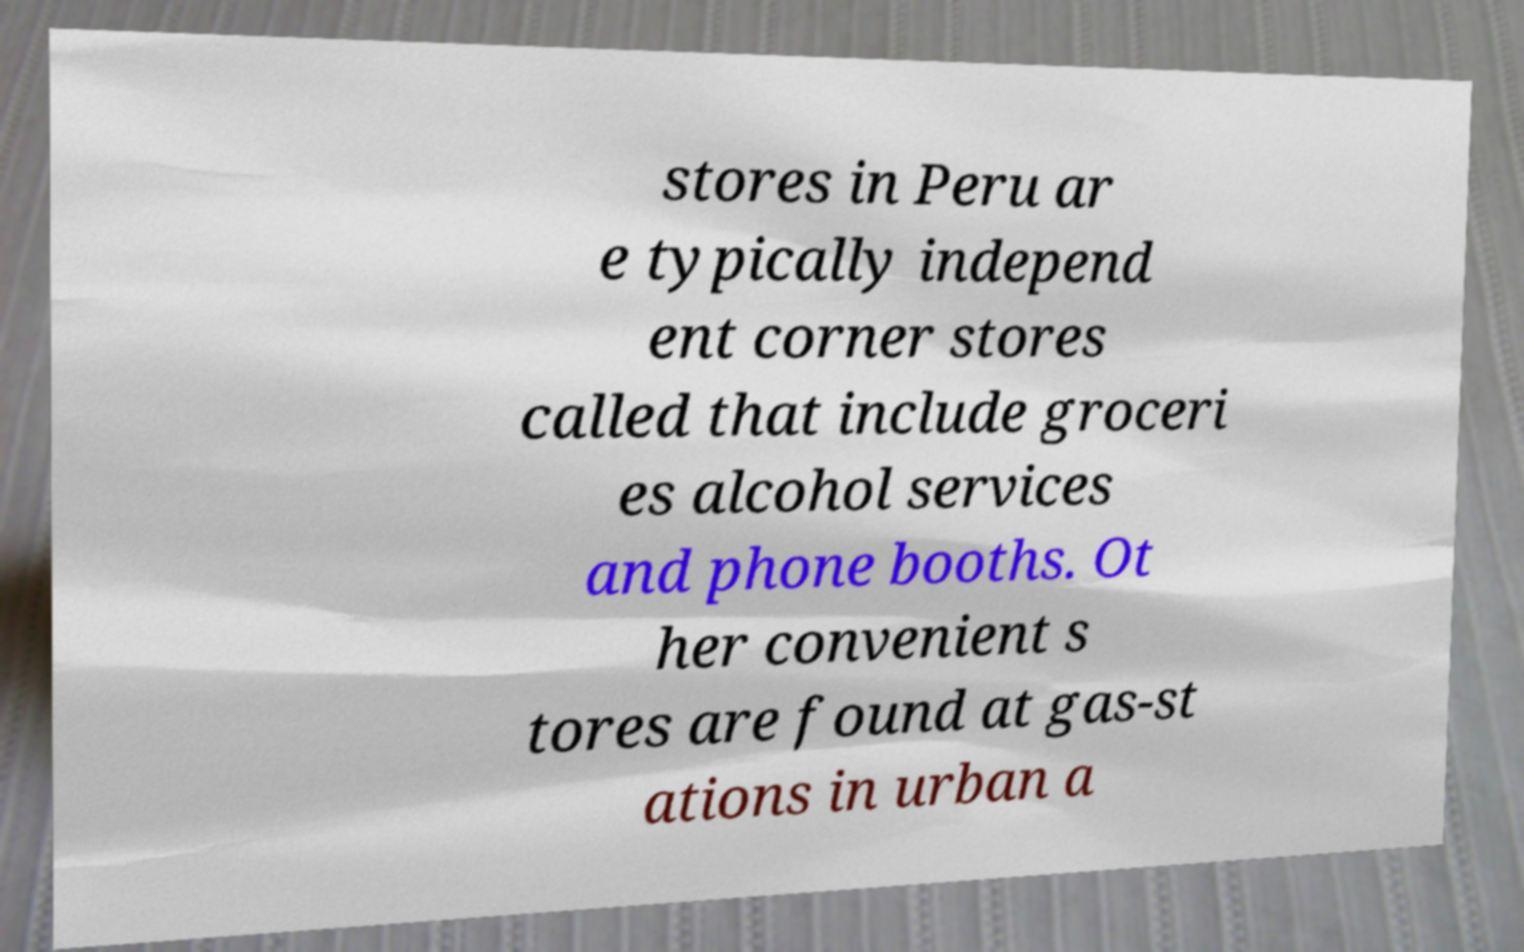Please identify and transcribe the text found in this image. stores in Peru ar e typically independ ent corner stores called that include groceri es alcohol services and phone booths. Ot her convenient s tores are found at gas-st ations in urban a 